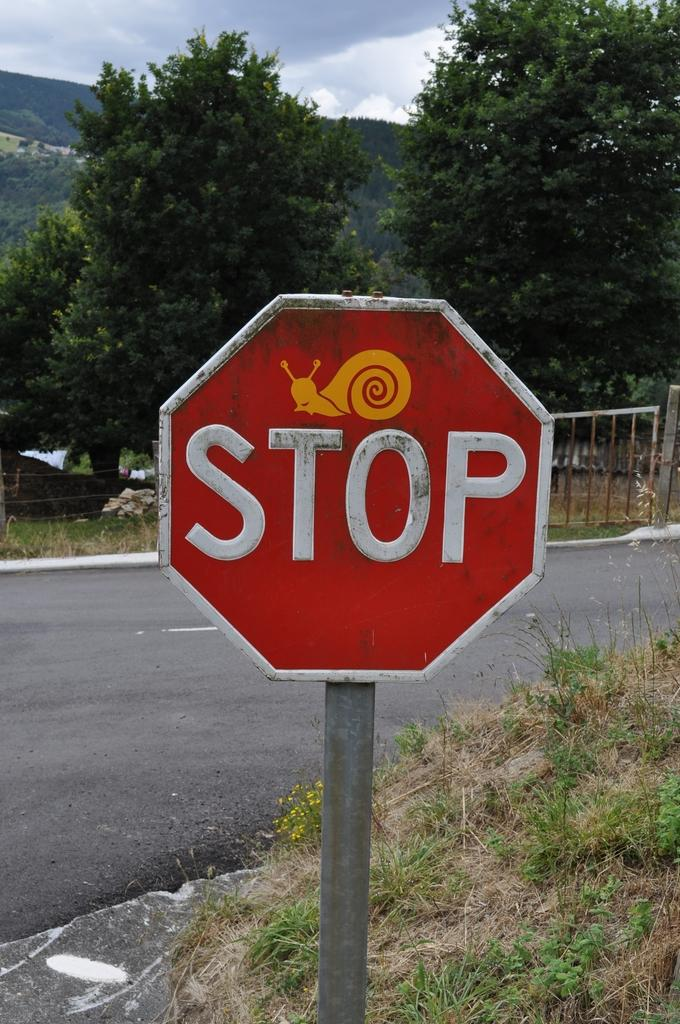Provide a one-sentence caption for the provided image. Large Stop sign with a sticker of a snail on it. 